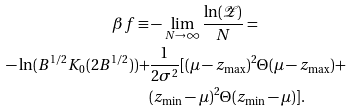<formula> <loc_0><loc_0><loc_500><loc_500>\beta f \equiv & - \lim _ { N \rightarrow \infty } \frac { \ln ( \mathcal { Z } ) } { N } = \\ - \ln ( B ^ { 1 / 2 } K _ { 0 } ( 2 B ^ { 1 / 2 } ) ) + & \frac { 1 } { 2 \sigma ^ { 2 } } [ ( \mu - z _ { \max } ) ^ { 2 } \Theta ( \mu - z _ { \max } ) + \\ & ( z _ { \min } - \mu ) ^ { 2 } \Theta ( z _ { \min } - \mu ) ] .</formula> 